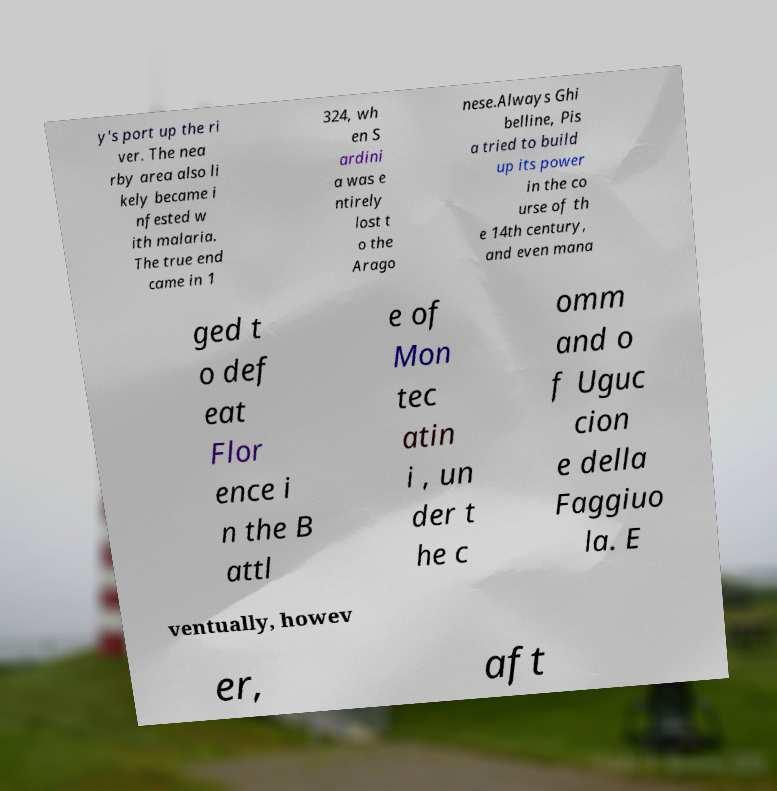Could you extract and type out the text from this image? y's port up the ri ver. The nea rby area also li kely became i nfested w ith malaria. The true end came in 1 324, wh en S ardini a was e ntirely lost t o the Arago nese.Always Ghi belline, Pis a tried to build up its power in the co urse of th e 14th century, and even mana ged t o def eat Flor ence i n the B attl e of Mon tec atin i , un der t he c omm and o f Uguc cion e della Faggiuo la. E ventually, howev er, aft 